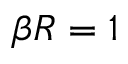Convert formula to latex. <formula><loc_0><loc_0><loc_500><loc_500>\beta R = 1</formula> 